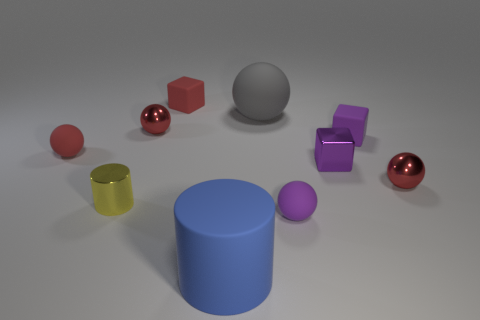Subtract all small rubber cubes. How many cubes are left? 1 Subtract all red cubes. How many cubes are left? 2 Subtract all cyan cubes. Subtract all purple balls. How many cubes are left? 3 Subtract all brown cylinders. How many green cubes are left? 0 Subtract all yellow cylinders. Subtract all purple metal blocks. How many objects are left? 8 Add 9 tiny yellow things. How many tiny yellow things are left? 10 Add 6 rubber blocks. How many rubber blocks exist? 8 Subtract 0 yellow cubes. How many objects are left? 10 Subtract all cylinders. How many objects are left? 8 Subtract 1 cubes. How many cubes are left? 2 